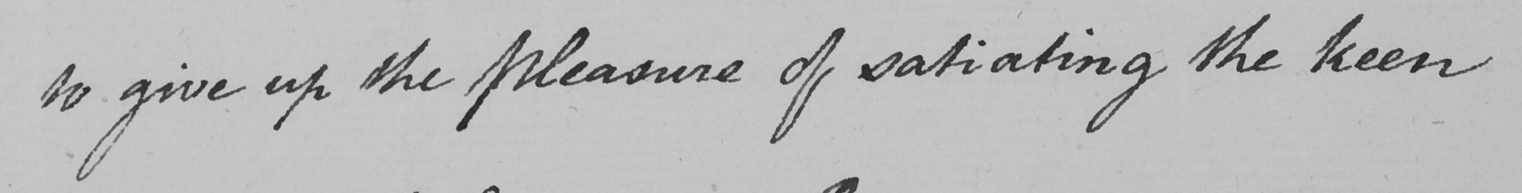Can you read and transcribe this handwriting? to give up the Pleasure of satiating the keen 